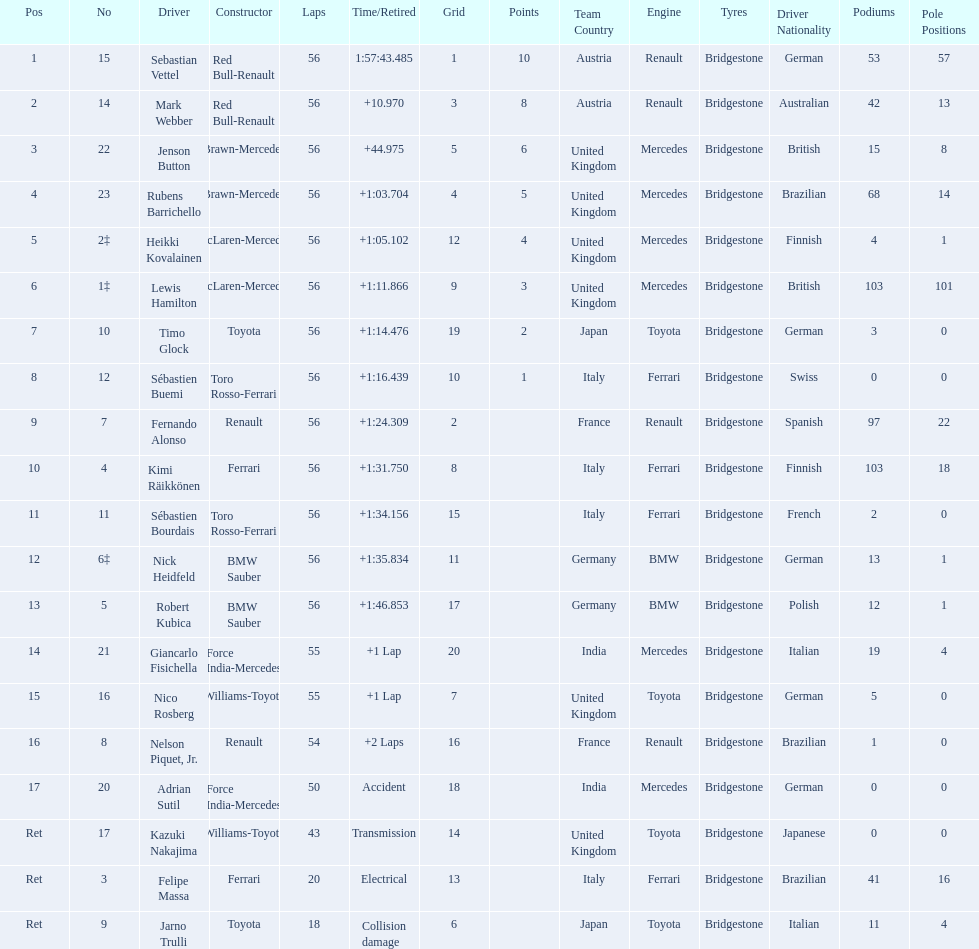What is the total number of drivers on the list? 20. 